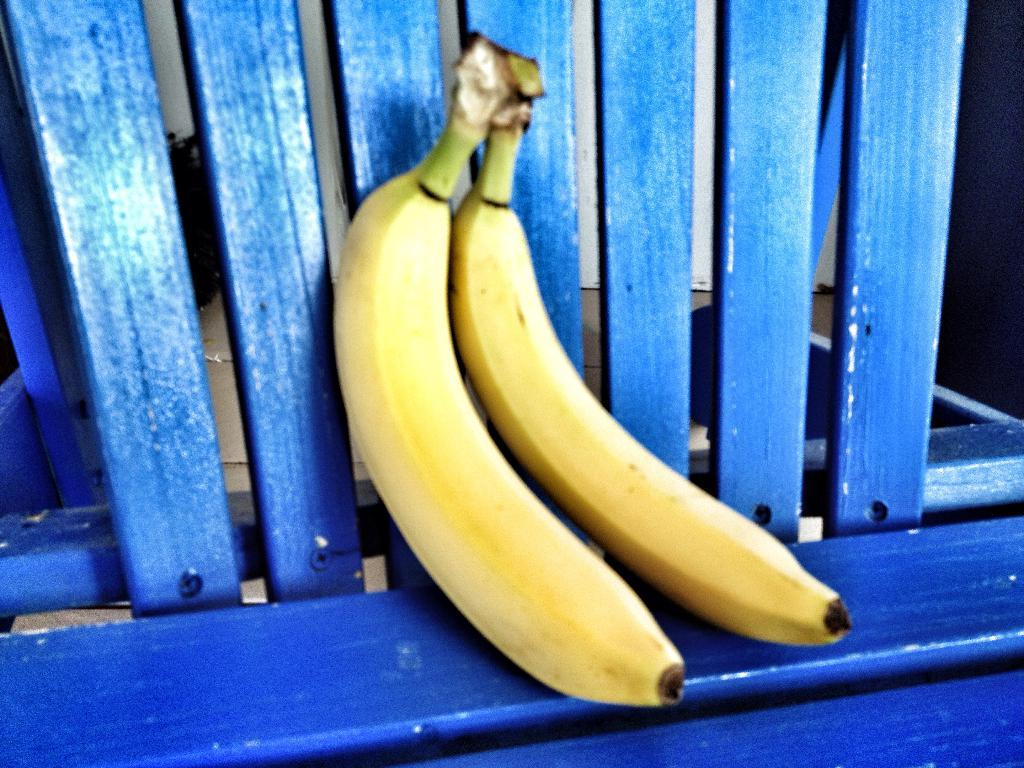What type of fruit is visible in the front of the image? There are two bananas in the front of the image. What object can be seen at the bottom of the image? There appears to be a bench at the bottom of the image. What is located in the background of the image? There is a wall in the background of the image. What type of curtain is hanging from the wall in the image? There is no curtain present in the image; only a wall is visible in the background. 